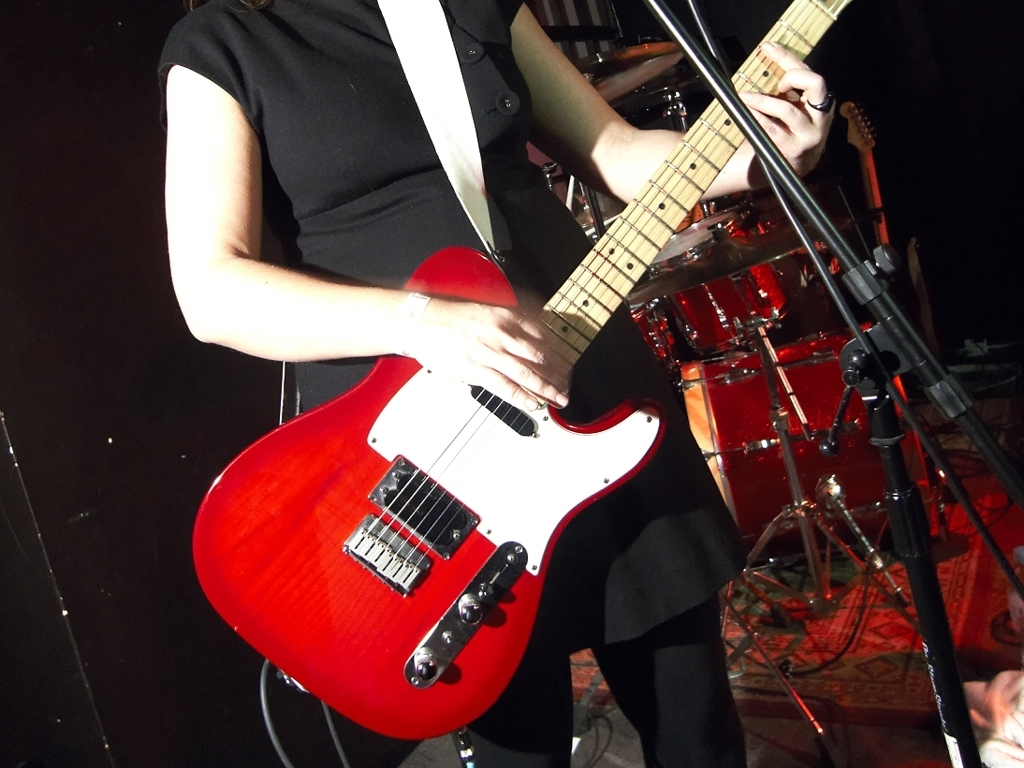Can you describe the setting of the photo? The photo seems to be taken at a live music venue. Indicators include the stage-like area, a microphone stand, and a drum set in the background, suggesting a performance is taking place or about to begin. 